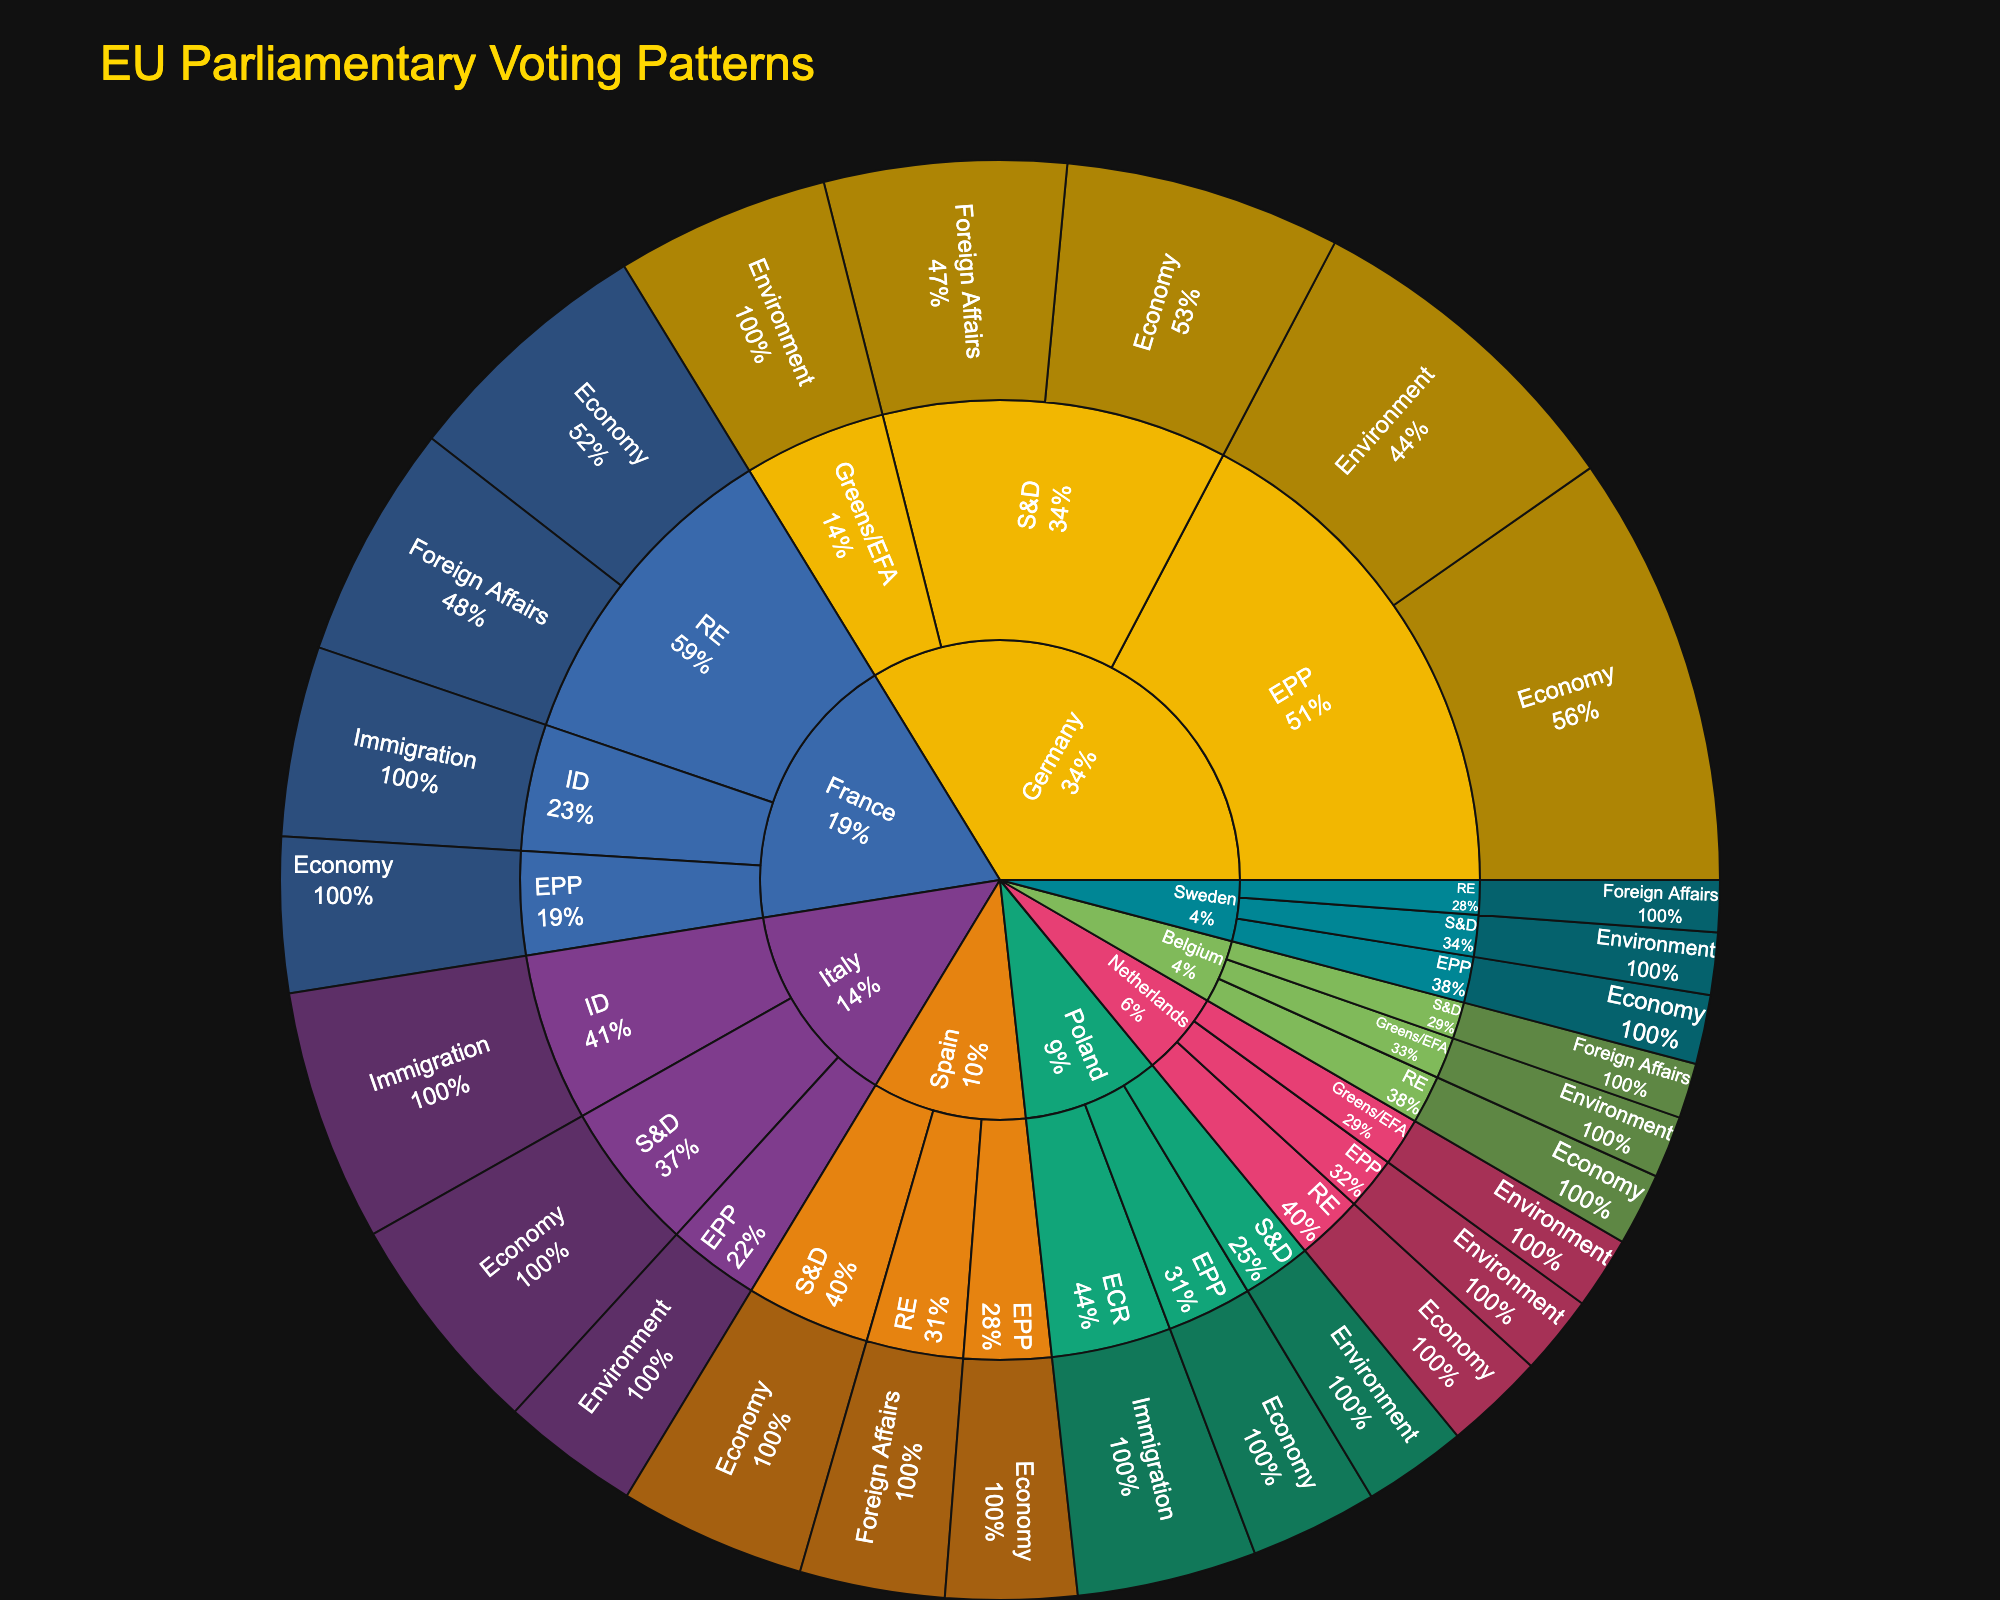What country has the highest number of votes in the Economy policy area? To find this, look at the segments under each country for the Economy policy area. Germany has 125 votes, France has 74, Italy has 65, Spain has 54, and so on. Germany has the highest number.
Answer: Germany Which political group in France has the highest number of votes in Foreign Affairs? Within the France segment, look at the votes for the Foreign Affairs policy area. France has 68 votes in the Foreign Affairs policy area under the RE political group. No other political group under France has votes in Foreign Affairs.
Answer: RE What is the total number of votes in the Environment policy area across all countries? Add up the votes for the Environment policy area from each country. The votes are as follows: Germany (98 + 62), Italy (40), Poland (30), Netherlands (23 + 21), Sweden (18), and Belgium (18). Summing these gives: 98 + 62 + 40 + 30 + 23 + 21 + 18 + 18 = 310.
Answer: 310 Which country has the most diverse representation across political groups? The diversity can be assessed by counting the number of different political groups represented under each country. Germany has EPP, S&D, and Greens/EFA. France has RE, ID, and EPP. Italy has ID, S&D, and EPP, and so on. Germany, France, and Italy all have three political groups each, indicating they are the most diverse.
Answer: Germany, France, Italy What is the smallest number of votes in the Immigration policy area? Look at the votes for the Immigration policy area. France (55) and Poland (52) have votes in this area. The smallest number is 52 from Poland.
Answer: 52 Among the S&D group, which country casts the highest number of votes in the Economy policy area? Within the S&D group, look at the Economy policy area votes for each country. Germany has 80 votes and Italy has 65 votes. Germany has the highest.
Answer: Germany Compare the total votes in the Foreign Affairs policy area for France and Spain. Which country has more votes? For Foreign Affairs, France has 68 votes, and Spain has 42 votes. Comparing these, France has more votes than Spain.
Answer: France Which country has the highest votes in a single segment? Determine the highest number of votes in any single country-policy combination. Germany has 125 votes in the Economy policy area, which is higher than any other segment.
Answer: Germany What is the total vote share (%) of the Greens/EFA political group in Germany? Look at the total number of votes cast in Germany (125 + 98 + 80 + 70 + 62 = 435 votes), and then the votes for the Greens/EFA group (62). Divide the Greens/EFA votes by the total and multiply by 100 to get the percentage: (62/435) * 100 ≈ 14.25%.
Answer: 14.25% What are the votes for the RE group in the Economy policy area, across all countries? Look at the RE group's votes in the Economy policy area for each country: France (74), Netherlands (29), Belgium (21). Summing these gives: 74 + 29 + 21 = 124.
Answer: 124 